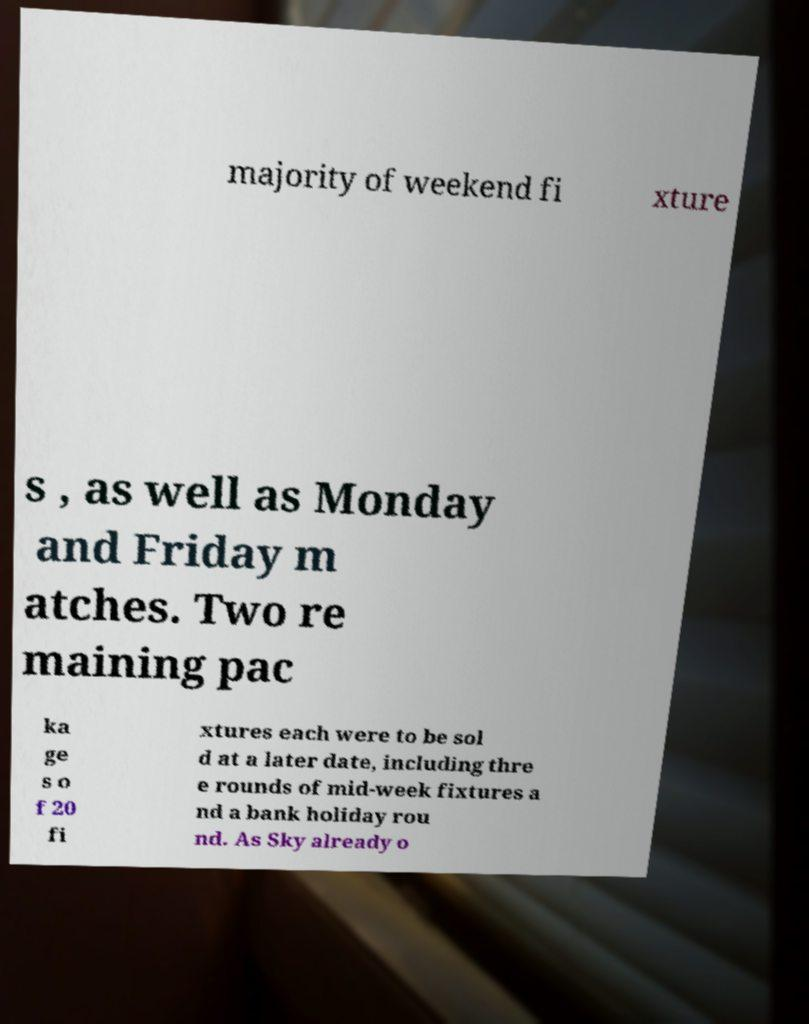Can you read and provide the text displayed in the image?This photo seems to have some interesting text. Can you extract and type it out for me? majority of weekend fi xture s , as well as Monday and Friday m atches. Two re maining pac ka ge s o f 20 fi xtures each were to be sol d at a later date, including thre e rounds of mid-week fixtures a nd a bank holiday rou nd. As Sky already o 